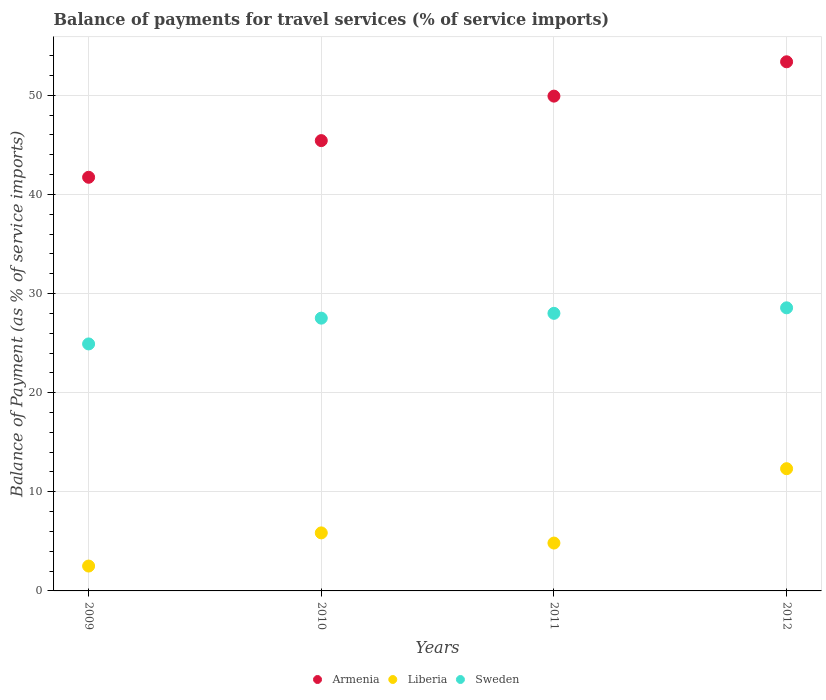What is the balance of payments for travel services in Armenia in 2009?
Your response must be concise. 41.73. Across all years, what is the maximum balance of payments for travel services in Sweden?
Your answer should be compact. 28.56. Across all years, what is the minimum balance of payments for travel services in Armenia?
Make the answer very short. 41.73. In which year was the balance of payments for travel services in Armenia maximum?
Your answer should be compact. 2012. In which year was the balance of payments for travel services in Sweden minimum?
Provide a succinct answer. 2009. What is the total balance of payments for travel services in Liberia in the graph?
Give a very brief answer. 25.52. What is the difference between the balance of payments for travel services in Liberia in 2010 and that in 2011?
Give a very brief answer. 1.03. What is the difference between the balance of payments for travel services in Armenia in 2011 and the balance of payments for travel services in Liberia in 2009?
Your answer should be compact. 47.41. What is the average balance of payments for travel services in Sweden per year?
Offer a terse response. 27.25. In the year 2010, what is the difference between the balance of payments for travel services in Armenia and balance of payments for travel services in Sweden?
Offer a very short reply. 17.91. What is the ratio of the balance of payments for travel services in Sweden in 2009 to that in 2012?
Give a very brief answer. 0.87. What is the difference between the highest and the second highest balance of payments for travel services in Liberia?
Ensure brevity in your answer.  6.48. What is the difference between the highest and the lowest balance of payments for travel services in Liberia?
Provide a short and direct response. 9.82. Is the balance of payments for travel services in Armenia strictly greater than the balance of payments for travel services in Sweden over the years?
Provide a succinct answer. Yes. Is the balance of payments for travel services in Liberia strictly less than the balance of payments for travel services in Sweden over the years?
Provide a succinct answer. Yes. How many dotlines are there?
Give a very brief answer. 3. What is the difference between two consecutive major ticks on the Y-axis?
Provide a succinct answer. 10. Are the values on the major ticks of Y-axis written in scientific E-notation?
Provide a succinct answer. No. Does the graph contain any zero values?
Your answer should be compact. No. What is the title of the graph?
Your answer should be compact. Balance of payments for travel services (% of service imports). Does "Togo" appear as one of the legend labels in the graph?
Provide a succinct answer. No. What is the label or title of the Y-axis?
Keep it short and to the point. Balance of Payment (as % of service imports). What is the Balance of Payment (as % of service imports) of Armenia in 2009?
Offer a terse response. 41.73. What is the Balance of Payment (as % of service imports) of Liberia in 2009?
Provide a succinct answer. 2.51. What is the Balance of Payment (as % of service imports) of Sweden in 2009?
Your answer should be compact. 24.92. What is the Balance of Payment (as % of service imports) in Armenia in 2010?
Your answer should be very brief. 45.43. What is the Balance of Payment (as % of service imports) of Liberia in 2010?
Your response must be concise. 5.85. What is the Balance of Payment (as % of service imports) in Sweden in 2010?
Provide a short and direct response. 27.52. What is the Balance of Payment (as % of service imports) of Armenia in 2011?
Keep it short and to the point. 49.91. What is the Balance of Payment (as % of service imports) in Liberia in 2011?
Keep it short and to the point. 4.83. What is the Balance of Payment (as % of service imports) in Sweden in 2011?
Provide a short and direct response. 28. What is the Balance of Payment (as % of service imports) in Armenia in 2012?
Give a very brief answer. 53.38. What is the Balance of Payment (as % of service imports) in Liberia in 2012?
Offer a terse response. 12.33. What is the Balance of Payment (as % of service imports) of Sweden in 2012?
Provide a succinct answer. 28.56. Across all years, what is the maximum Balance of Payment (as % of service imports) in Armenia?
Your answer should be compact. 53.38. Across all years, what is the maximum Balance of Payment (as % of service imports) in Liberia?
Your response must be concise. 12.33. Across all years, what is the maximum Balance of Payment (as % of service imports) of Sweden?
Your answer should be compact. 28.56. Across all years, what is the minimum Balance of Payment (as % of service imports) in Armenia?
Your answer should be compact. 41.73. Across all years, what is the minimum Balance of Payment (as % of service imports) in Liberia?
Give a very brief answer. 2.51. Across all years, what is the minimum Balance of Payment (as % of service imports) in Sweden?
Ensure brevity in your answer.  24.92. What is the total Balance of Payment (as % of service imports) in Armenia in the graph?
Provide a short and direct response. 190.45. What is the total Balance of Payment (as % of service imports) of Liberia in the graph?
Your answer should be compact. 25.52. What is the total Balance of Payment (as % of service imports) of Sweden in the graph?
Provide a succinct answer. 109. What is the difference between the Balance of Payment (as % of service imports) of Armenia in 2009 and that in 2010?
Make the answer very short. -3.7. What is the difference between the Balance of Payment (as % of service imports) of Liberia in 2009 and that in 2010?
Provide a short and direct response. -3.35. What is the difference between the Balance of Payment (as % of service imports) in Sweden in 2009 and that in 2010?
Offer a terse response. -2.6. What is the difference between the Balance of Payment (as % of service imports) in Armenia in 2009 and that in 2011?
Make the answer very short. -8.19. What is the difference between the Balance of Payment (as % of service imports) of Liberia in 2009 and that in 2011?
Make the answer very short. -2.32. What is the difference between the Balance of Payment (as % of service imports) of Sweden in 2009 and that in 2011?
Give a very brief answer. -3.09. What is the difference between the Balance of Payment (as % of service imports) in Armenia in 2009 and that in 2012?
Your answer should be very brief. -11.65. What is the difference between the Balance of Payment (as % of service imports) in Liberia in 2009 and that in 2012?
Your response must be concise. -9.82. What is the difference between the Balance of Payment (as % of service imports) of Sweden in 2009 and that in 2012?
Your answer should be very brief. -3.64. What is the difference between the Balance of Payment (as % of service imports) in Armenia in 2010 and that in 2011?
Your answer should be compact. -4.49. What is the difference between the Balance of Payment (as % of service imports) in Liberia in 2010 and that in 2011?
Your answer should be very brief. 1.03. What is the difference between the Balance of Payment (as % of service imports) of Sweden in 2010 and that in 2011?
Your answer should be very brief. -0.49. What is the difference between the Balance of Payment (as % of service imports) in Armenia in 2010 and that in 2012?
Give a very brief answer. -7.95. What is the difference between the Balance of Payment (as % of service imports) in Liberia in 2010 and that in 2012?
Your response must be concise. -6.48. What is the difference between the Balance of Payment (as % of service imports) of Sweden in 2010 and that in 2012?
Give a very brief answer. -1.04. What is the difference between the Balance of Payment (as % of service imports) of Armenia in 2011 and that in 2012?
Your answer should be very brief. -3.46. What is the difference between the Balance of Payment (as % of service imports) of Liberia in 2011 and that in 2012?
Keep it short and to the point. -7.5. What is the difference between the Balance of Payment (as % of service imports) in Sweden in 2011 and that in 2012?
Ensure brevity in your answer.  -0.56. What is the difference between the Balance of Payment (as % of service imports) of Armenia in 2009 and the Balance of Payment (as % of service imports) of Liberia in 2010?
Give a very brief answer. 35.87. What is the difference between the Balance of Payment (as % of service imports) in Armenia in 2009 and the Balance of Payment (as % of service imports) in Sweden in 2010?
Offer a very short reply. 14.21. What is the difference between the Balance of Payment (as % of service imports) in Liberia in 2009 and the Balance of Payment (as % of service imports) in Sweden in 2010?
Your response must be concise. -25.01. What is the difference between the Balance of Payment (as % of service imports) in Armenia in 2009 and the Balance of Payment (as % of service imports) in Liberia in 2011?
Provide a succinct answer. 36.9. What is the difference between the Balance of Payment (as % of service imports) of Armenia in 2009 and the Balance of Payment (as % of service imports) of Sweden in 2011?
Offer a terse response. 13.73. What is the difference between the Balance of Payment (as % of service imports) of Liberia in 2009 and the Balance of Payment (as % of service imports) of Sweden in 2011?
Your answer should be very brief. -25.49. What is the difference between the Balance of Payment (as % of service imports) of Armenia in 2009 and the Balance of Payment (as % of service imports) of Liberia in 2012?
Ensure brevity in your answer.  29.4. What is the difference between the Balance of Payment (as % of service imports) in Armenia in 2009 and the Balance of Payment (as % of service imports) in Sweden in 2012?
Your answer should be compact. 13.17. What is the difference between the Balance of Payment (as % of service imports) in Liberia in 2009 and the Balance of Payment (as % of service imports) in Sweden in 2012?
Your response must be concise. -26.05. What is the difference between the Balance of Payment (as % of service imports) of Armenia in 2010 and the Balance of Payment (as % of service imports) of Liberia in 2011?
Offer a very short reply. 40.6. What is the difference between the Balance of Payment (as % of service imports) in Armenia in 2010 and the Balance of Payment (as % of service imports) in Sweden in 2011?
Your answer should be very brief. 17.42. What is the difference between the Balance of Payment (as % of service imports) in Liberia in 2010 and the Balance of Payment (as % of service imports) in Sweden in 2011?
Your response must be concise. -22.15. What is the difference between the Balance of Payment (as % of service imports) in Armenia in 2010 and the Balance of Payment (as % of service imports) in Liberia in 2012?
Your answer should be very brief. 33.1. What is the difference between the Balance of Payment (as % of service imports) of Armenia in 2010 and the Balance of Payment (as % of service imports) of Sweden in 2012?
Provide a short and direct response. 16.87. What is the difference between the Balance of Payment (as % of service imports) in Liberia in 2010 and the Balance of Payment (as % of service imports) in Sweden in 2012?
Your response must be concise. -22.71. What is the difference between the Balance of Payment (as % of service imports) of Armenia in 2011 and the Balance of Payment (as % of service imports) of Liberia in 2012?
Keep it short and to the point. 37.58. What is the difference between the Balance of Payment (as % of service imports) in Armenia in 2011 and the Balance of Payment (as % of service imports) in Sweden in 2012?
Keep it short and to the point. 21.36. What is the difference between the Balance of Payment (as % of service imports) of Liberia in 2011 and the Balance of Payment (as % of service imports) of Sweden in 2012?
Your answer should be compact. -23.73. What is the average Balance of Payment (as % of service imports) of Armenia per year?
Provide a succinct answer. 47.61. What is the average Balance of Payment (as % of service imports) in Liberia per year?
Keep it short and to the point. 6.38. What is the average Balance of Payment (as % of service imports) in Sweden per year?
Make the answer very short. 27.25. In the year 2009, what is the difference between the Balance of Payment (as % of service imports) in Armenia and Balance of Payment (as % of service imports) in Liberia?
Offer a terse response. 39.22. In the year 2009, what is the difference between the Balance of Payment (as % of service imports) in Armenia and Balance of Payment (as % of service imports) in Sweden?
Your answer should be compact. 16.81. In the year 2009, what is the difference between the Balance of Payment (as % of service imports) of Liberia and Balance of Payment (as % of service imports) of Sweden?
Your answer should be very brief. -22.41. In the year 2010, what is the difference between the Balance of Payment (as % of service imports) in Armenia and Balance of Payment (as % of service imports) in Liberia?
Offer a terse response. 39.57. In the year 2010, what is the difference between the Balance of Payment (as % of service imports) of Armenia and Balance of Payment (as % of service imports) of Sweden?
Offer a terse response. 17.91. In the year 2010, what is the difference between the Balance of Payment (as % of service imports) in Liberia and Balance of Payment (as % of service imports) in Sweden?
Provide a short and direct response. -21.66. In the year 2011, what is the difference between the Balance of Payment (as % of service imports) in Armenia and Balance of Payment (as % of service imports) in Liberia?
Your response must be concise. 45.09. In the year 2011, what is the difference between the Balance of Payment (as % of service imports) of Armenia and Balance of Payment (as % of service imports) of Sweden?
Your response must be concise. 21.91. In the year 2011, what is the difference between the Balance of Payment (as % of service imports) of Liberia and Balance of Payment (as % of service imports) of Sweden?
Your answer should be compact. -23.17. In the year 2012, what is the difference between the Balance of Payment (as % of service imports) of Armenia and Balance of Payment (as % of service imports) of Liberia?
Your answer should be very brief. 41.05. In the year 2012, what is the difference between the Balance of Payment (as % of service imports) of Armenia and Balance of Payment (as % of service imports) of Sweden?
Offer a very short reply. 24.82. In the year 2012, what is the difference between the Balance of Payment (as % of service imports) of Liberia and Balance of Payment (as % of service imports) of Sweden?
Your response must be concise. -16.23. What is the ratio of the Balance of Payment (as % of service imports) in Armenia in 2009 to that in 2010?
Keep it short and to the point. 0.92. What is the ratio of the Balance of Payment (as % of service imports) in Liberia in 2009 to that in 2010?
Make the answer very short. 0.43. What is the ratio of the Balance of Payment (as % of service imports) in Sweden in 2009 to that in 2010?
Keep it short and to the point. 0.91. What is the ratio of the Balance of Payment (as % of service imports) of Armenia in 2009 to that in 2011?
Ensure brevity in your answer.  0.84. What is the ratio of the Balance of Payment (as % of service imports) in Liberia in 2009 to that in 2011?
Your answer should be very brief. 0.52. What is the ratio of the Balance of Payment (as % of service imports) in Sweden in 2009 to that in 2011?
Ensure brevity in your answer.  0.89. What is the ratio of the Balance of Payment (as % of service imports) in Armenia in 2009 to that in 2012?
Make the answer very short. 0.78. What is the ratio of the Balance of Payment (as % of service imports) in Liberia in 2009 to that in 2012?
Provide a short and direct response. 0.2. What is the ratio of the Balance of Payment (as % of service imports) of Sweden in 2009 to that in 2012?
Give a very brief answer. 0.87. What is the ratio of the Balance of Payment (as % of service imports) in Armenia in 2010 to that in 2011?
Ensure brevity in your answer.  0.91. What is the ratio of the Balance of Payment (as % of service imports) of Liberia in 2010 to that in 2011?
Your answer should be compact. 1.21. What is the ratio of the Balance of Payment (as % of service imports) of Sweden in 2010 to that in 2011?
Offer a terse response. 0.98. What is the ratio of the Balance of Payment (as % of service imports) in Armenia in 2010 to that in 2012?
Offer a very short reply. 0.85. What is the ratio of the Balance of Payment (as % of service imports) of Liberia in 2010 to that in 2012?
Your response must be concise. 0.47. What is the ratio of the Balance of Payment (as % of service imports) of Sweden in 2010 to that in 2012?
Ensure brevity in your answer.  0.96. What is the ratio of the Balance of Payment (as % of service imports) of Armenia in 2011 to that in 2012?
Ensure brevity in your answer.  0.94. What is the ratio of the Balance of Payment (as % of service imports) in Liberia in 2011 to that in 2012?
Keep it short and to the point. 0.39. What is the ratio of the Balance of Payment (as % of service imports) of Sweden in 2011 to that in 2012?
Your answer should be very brief. 0.98. What is the difference between the highest and the second highest Balance of Payment (as % of service imports) of Armenia?
Offer a very short reply. 3.46. What is the difference between the highest and the second highest Balance of Payment (as % of service imports) of Liberia?
Keep it short and to the point. 6.48. What is the difference between the highest and the second highest Balance of Payment (as % of service imports) in Sweden?
Make the answer very short. 0.56. What is the difference between the highest and the lowest Balance of Payment (as % of service imports) of Armenia?
Provide a short and direct response. 11.65. What is the difference between the highest and the lowest Balance of Payment (as % of service imports) of Liberia?
Your response must be concise. 9.82. What is the difference between the highest and the lowest Balance of Payment (as % of service imports) in Sweden?
Provide a succinct answer. 3.64. 